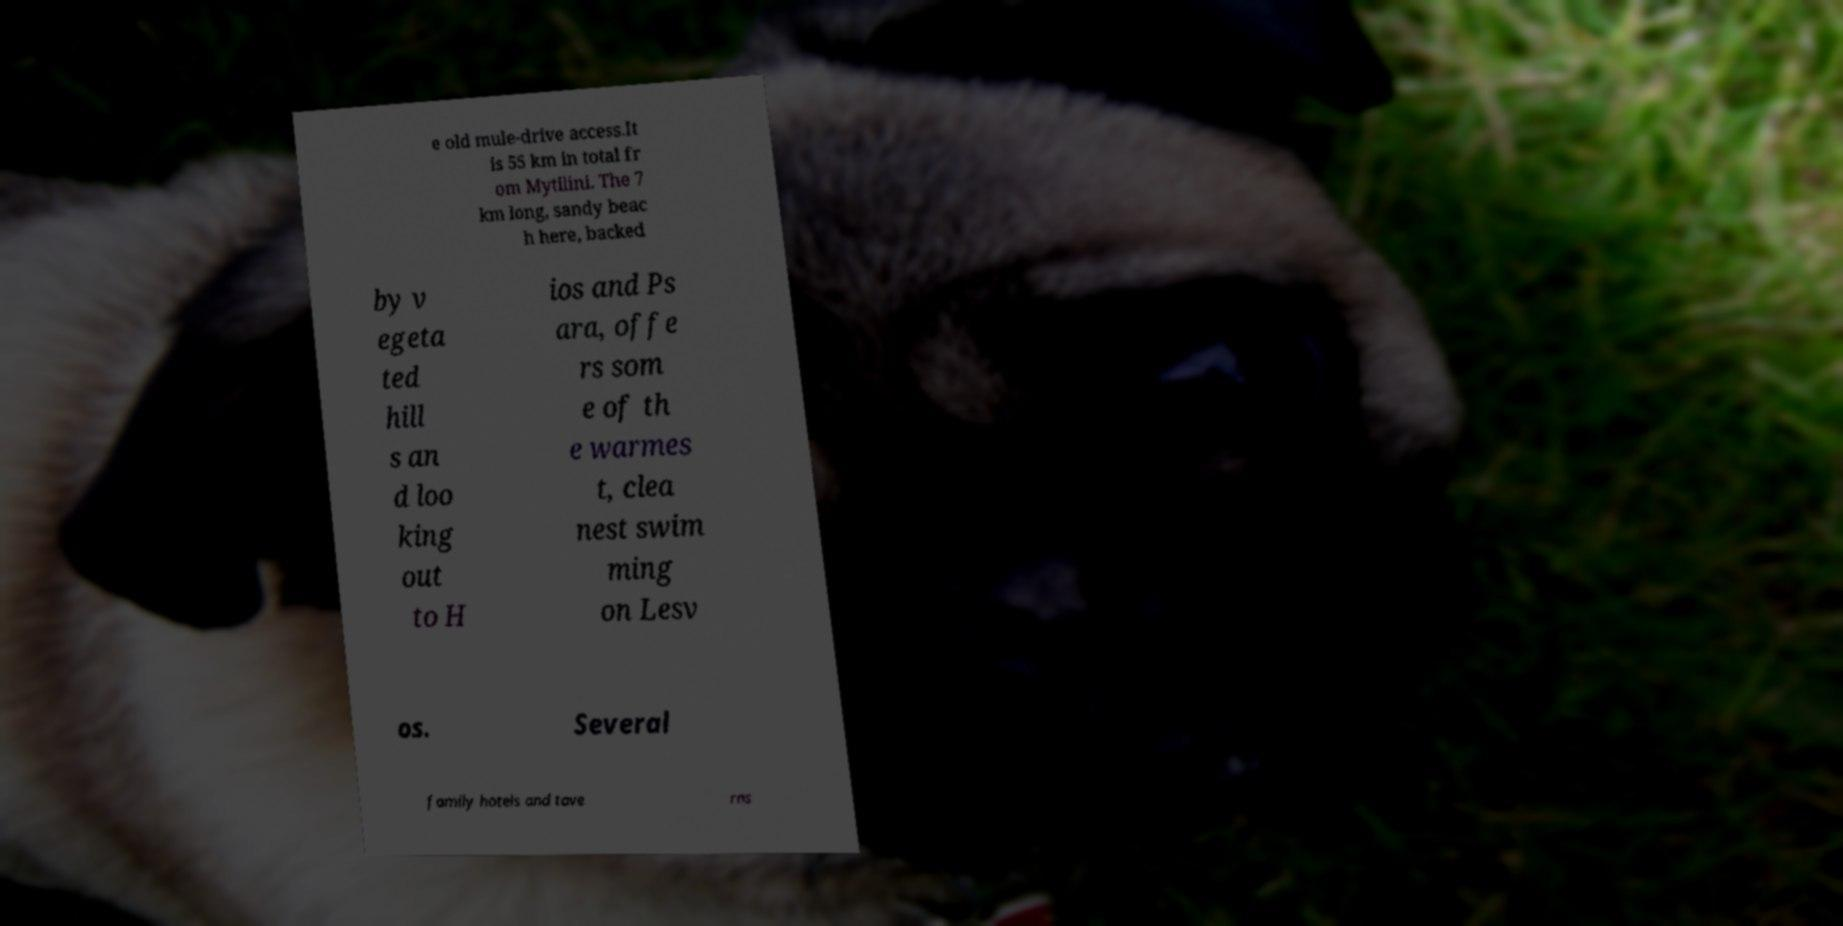What messages or text are displayed in this image? I need them in a readable, typed format. e old mule-drive access.It is 55 km in total fr om Mytilini. The 7 km long, sandy beac h here, backed by v egeta ted hill s an d loo king out to H ios and Ps ara, offe rs som e of th e warmes t, clea nest swim ming on Lesv os. Several family hotels and tave rns 